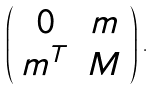<formula> <loc_0><loc_0><loc_500><loc_500>\left ( \begin{array} { c c } 0 & m \\ m ^ { T } & M \end{array} \right ) \, .</formula> 